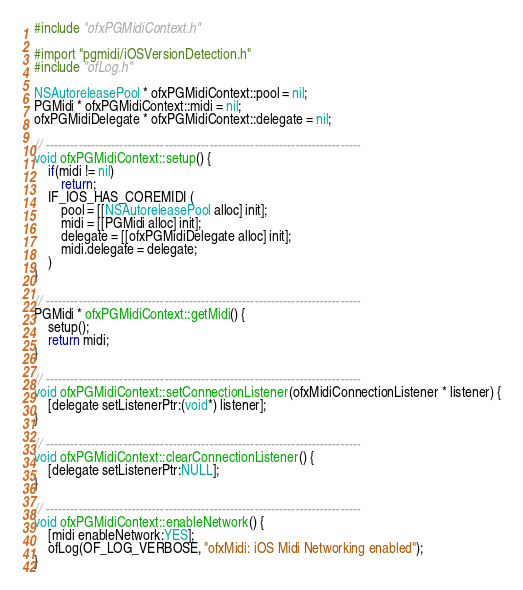Convert code to text. <code><loc_0><loc_0><loc_500><loc_500><_ObjectiveC_>#include "ofxPGMidiContext.h"

#import "pgmidi/iOSVersionDetection.h"
#include "ofLog.h"

NSAutoreleasePool * ofxPGMidiContext::pool = nil;
PGMidi * ofxPGMidiContext::midi = nil;
ofxPGMidiDelegate * ofxPGMidiContext::delegate = nil;

// -----------------------------------------------------------------------------
void ofxPGMidiContext::setup() {
	if(midi != nil)
		return;
	IF_IOS_HAS_COREMIDI (
		pool = [[NSAutoreleasePool alloc] init];
		midi = [[PGMidi alloc] init];
		delegate = [[ofxPGMidiDelegate alloc] init];
		midi.delegate = delegate;
	)
}

// -----------------------------------------------------------------------------
PGMidi * ofxPGMidiContext::getMidi() {
	setup();
	return midi;
}

// -----------------------------------------------------------------------------
void ofxPGMidiContext::setConnectionListener(ofxMidiConnectionListener * listener) {
	[delegate setListenerPtr:(void*) listener];
}

// -----------------------------------------------------------------------------
void ofxPGMidiContext::clearConnectionListener() {
	[delegate setListenerPtr:NULL];
}

// -----------------------------------------------------------------------------
void ofxPGMidiContext::enableNetwork() {
	[midi enableNetwork:YES];
	ofLog(OF_LOG_VERBOSE, "ofxMidi: iOS Midi Networking enabled");
}
</code> 